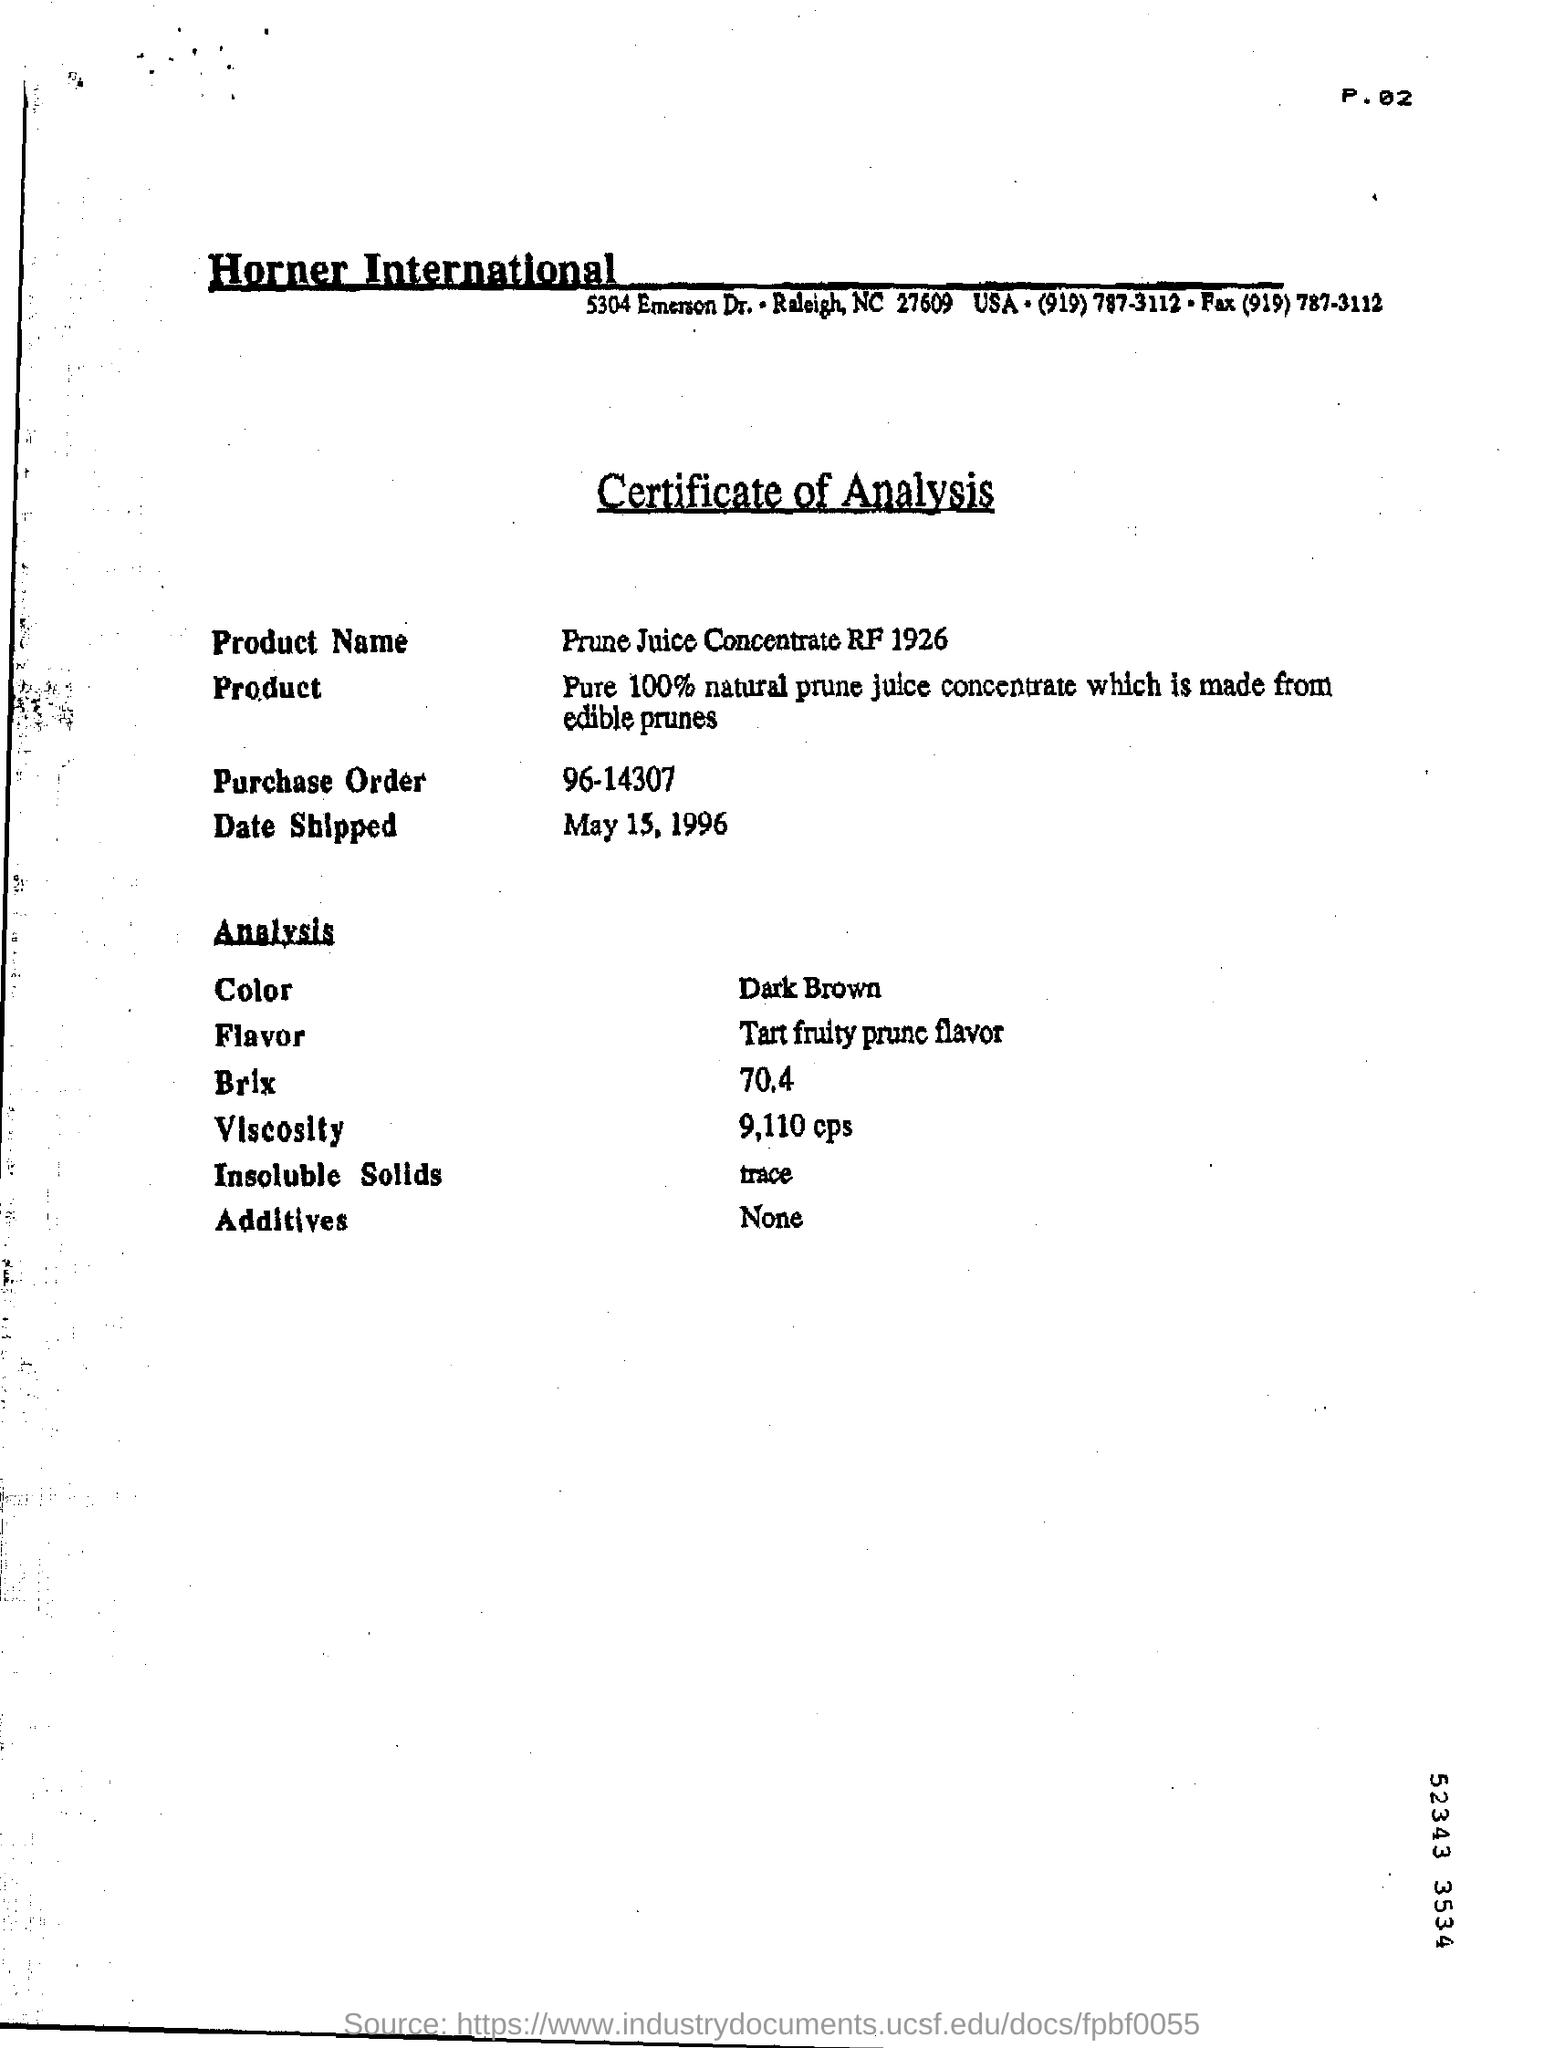What type of document is this?
Offer a terse response. Certificate of Analysis. What is the Product Name mentioned in the document?
Your response must be concise. Prune Juice Concentrate RF 1926. What is the Purchase Order given in the document?
Make the answer very short. 96-14307. On which date, the product is shipped?
Provide a short and direct response. May 15, 1996. What is the color of the product shown in the analysis?
Ensure brevity in your answer.  Dark Brown. What is the viscosity of the product as per the analysis?
Offer a terse response. 9,110 cps. What is the page no mentioned in this document?
Offer a terse response. P.02. 